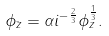<formula> <loc_0><loc_0><loc_500><loc_500>\phi _ { \bar { z } } = \alpha i ^ { - \frac { 2 } { 3 } } \phi _ { z } ^ { \frac { 1 } { 3 } } .</formula> 